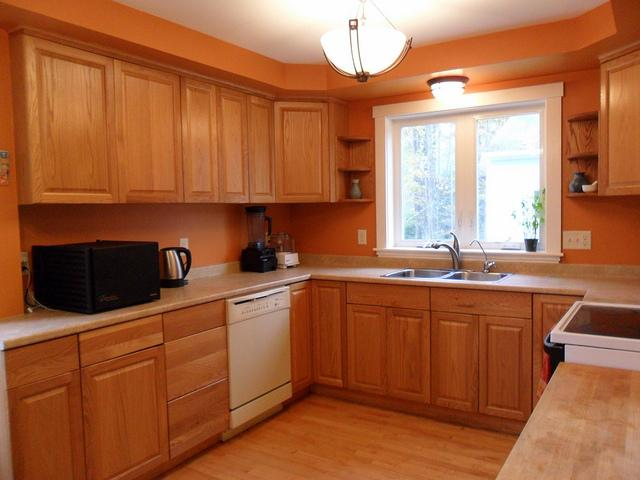What is the black appliance by the corner called? Please explain your reasoning. blender. The appliance is a blender. 